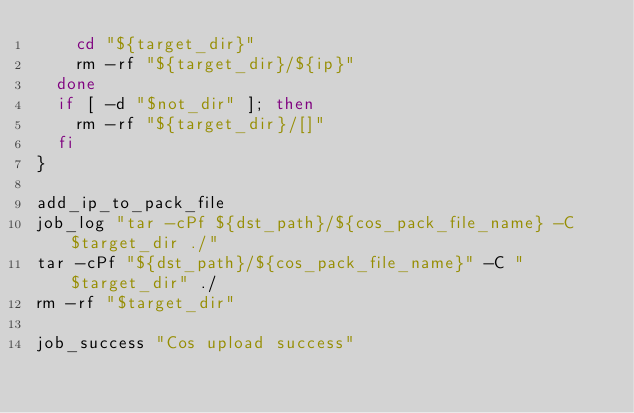Convert code to text. <code><loc_0><loc_0><loc_500><loc_500><_Bash_>    cd "${target_dir}"
    rm -rf "${target_dir}/${ip}"
  done
  if [ -d "$not_dir" ]; then
    rm -rf "${target_dir}/[]"
  fi
}

add_ip_to_pack_file
job_log "tar -cPf ${dst_path}/${cos_pack_file_name} -C $target_dir ./"
tar -cPf "${dst_path}/${cos_pack_file_name}" -C "$target_dir" ./
rm -rf "$target_dir"

job_success "Cos upload success"
</code> 